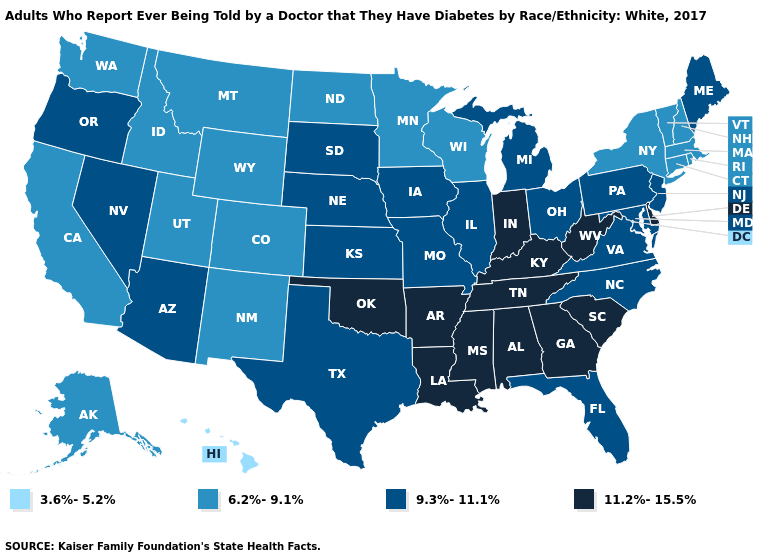What is the value of Florida?
Quick response, please. 9.3%-11.1%. Name the states that have a value in the range 3.6%-5.2%?
Write a very short answer. Hawaii. Does Kentucky have a lower value than Vermont?
Give a very brief answer. No. What is the value of Florida?
Write a very short answer. 9.3%-11.1%. What is the value of Maine?
Concise answer only. 9.3%-11.1%. Name the states that have a value in the range 9.3%-11.1%?
Answer briefly. Arizona, Florida, Illinois, Iowa, Kansas, Maine, Maryland, Michigan, Missouri, Nebraska, Nevada, New Jersey, North Carolina, Ohio, Oregon, Pennsylvania, South Dakota, Texas, Virginia. Does North Dakota have a lower value than West Virginia?
Answer briefly. Yes. What is the value of New Hampshire?
Keep it brief. 6.2%-9.1%. What is the value of Colorado?
Quick response, please. 6.2%-9.1%. Does Maine have the lowest value in the Northeast?
Answer briefly. No. What is the highest value in the South ?
Write a very short answer. 11.2%-15.5%. Name the states that have a value in the range 9.3%-11.1%?
Be succinct. Arizona, Florida, Illinois, Iowa, Kansas, Maine, Maryland, Michigan, Missouri, Nebraska, Nevada, New Jersey, North Carolina, Ohio, Oregon, Pennsylvania, South Dakota, Texas, Virginia. Which states hav the highest value in the MidWest?
Concise answer only. Indiana. What is the highest value in the West ?
Keep it brief. 9.3%-11.1%. Which states hav the highest value in the MidWest?
Keep it brief. Indiana. 